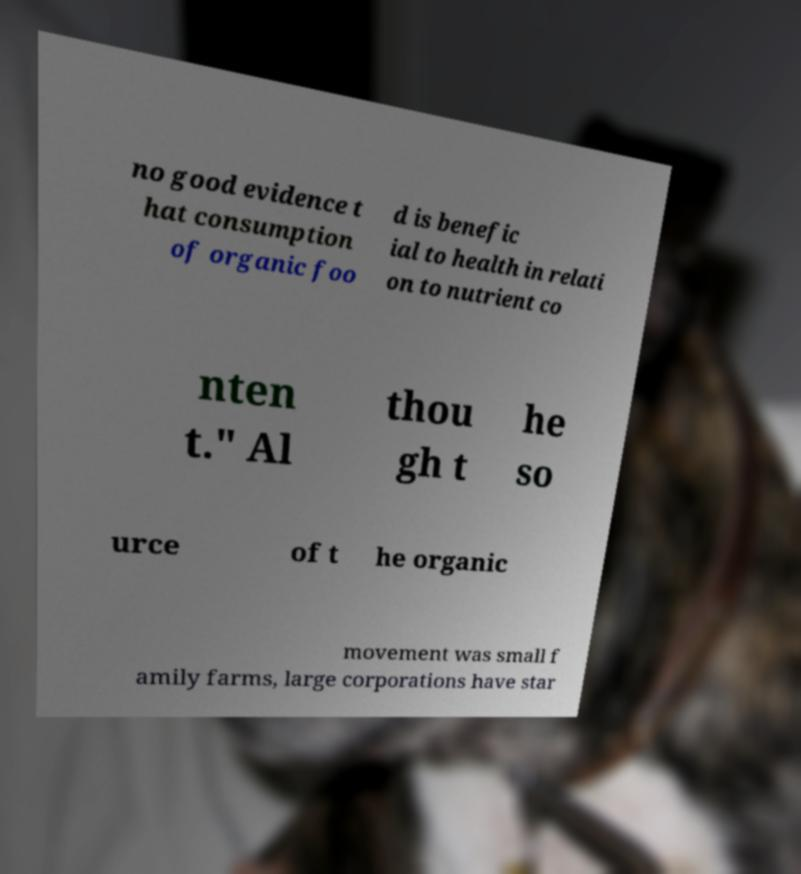Can you accurately transcribe the text from the provided image for me? no good evidence t hat consumption of organic foo d is benefic ial to health in relati on to nutrient co nten t." Al thou gh t he so urce of t he organic movement was small f amily farms, large corporations have star 